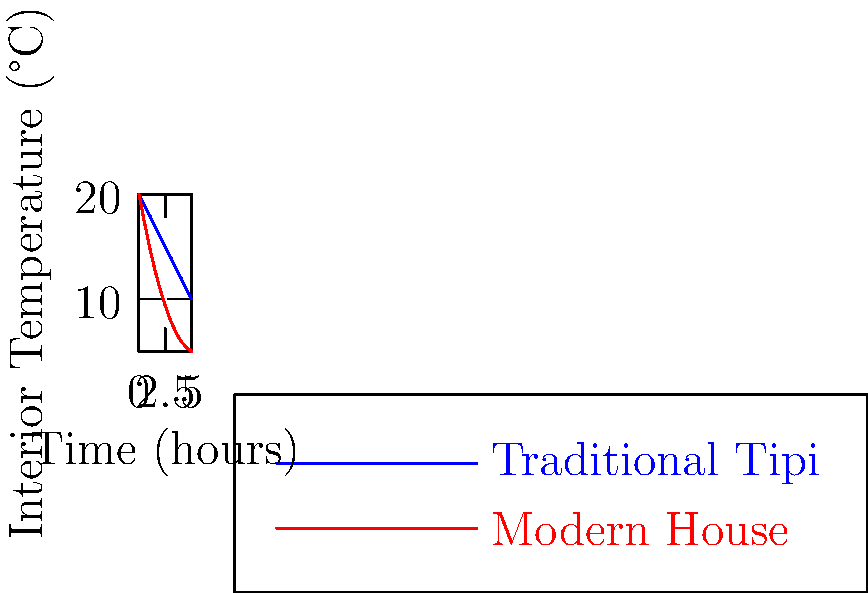Based on the graph showing the interior temperature change over time for a traditional Native American tipi and a modern house, which structure demonstrates better thermal insulation properties? Explain your reasoning using the concept of thermal resistance. To determine which structure has better thermal insulation properties, we need to analyze the rate of temperature change over time:

1. Observe the graph:
   - Blue line represents the traditional tipi
   - Red line represents the modern house

2. Compare the slopes:
   - The tipi's temperature decreases more slowly
   - The modern house's temperature drops more rapidly

3. Understand thermal resistance:
   - Higher thermal resistance (R-value) means better insulation
   - Better insulation results in slower heat loss

4. Apply the concept:
   - The slower temperature decrease in the tipi indicates higher thermal resistance
   - Higher thermal resistance implies better insulation properties

5. Calculate the rate of temperature change:
   - Tipi: $\frac{20°C - 10°C}{5 hours} = 2°C/hour$
   - Modern house: $\frac{20°C - 5°C}{5 hours} = 3°C/hour$

6. Interpret the results:
   - The tipi loses heat at a slower rate (2°C/hour)
   - The modern house loses heat faster (3°C/hour)

Therefore, the traditional Native American tipi demonstrates better thermal insulation properties due to its slower rate of heat loss, indicating a higher thermal resistance.
Answer: Traditional tipi; slower rate of heat loss indicates higher thermal resistance. 